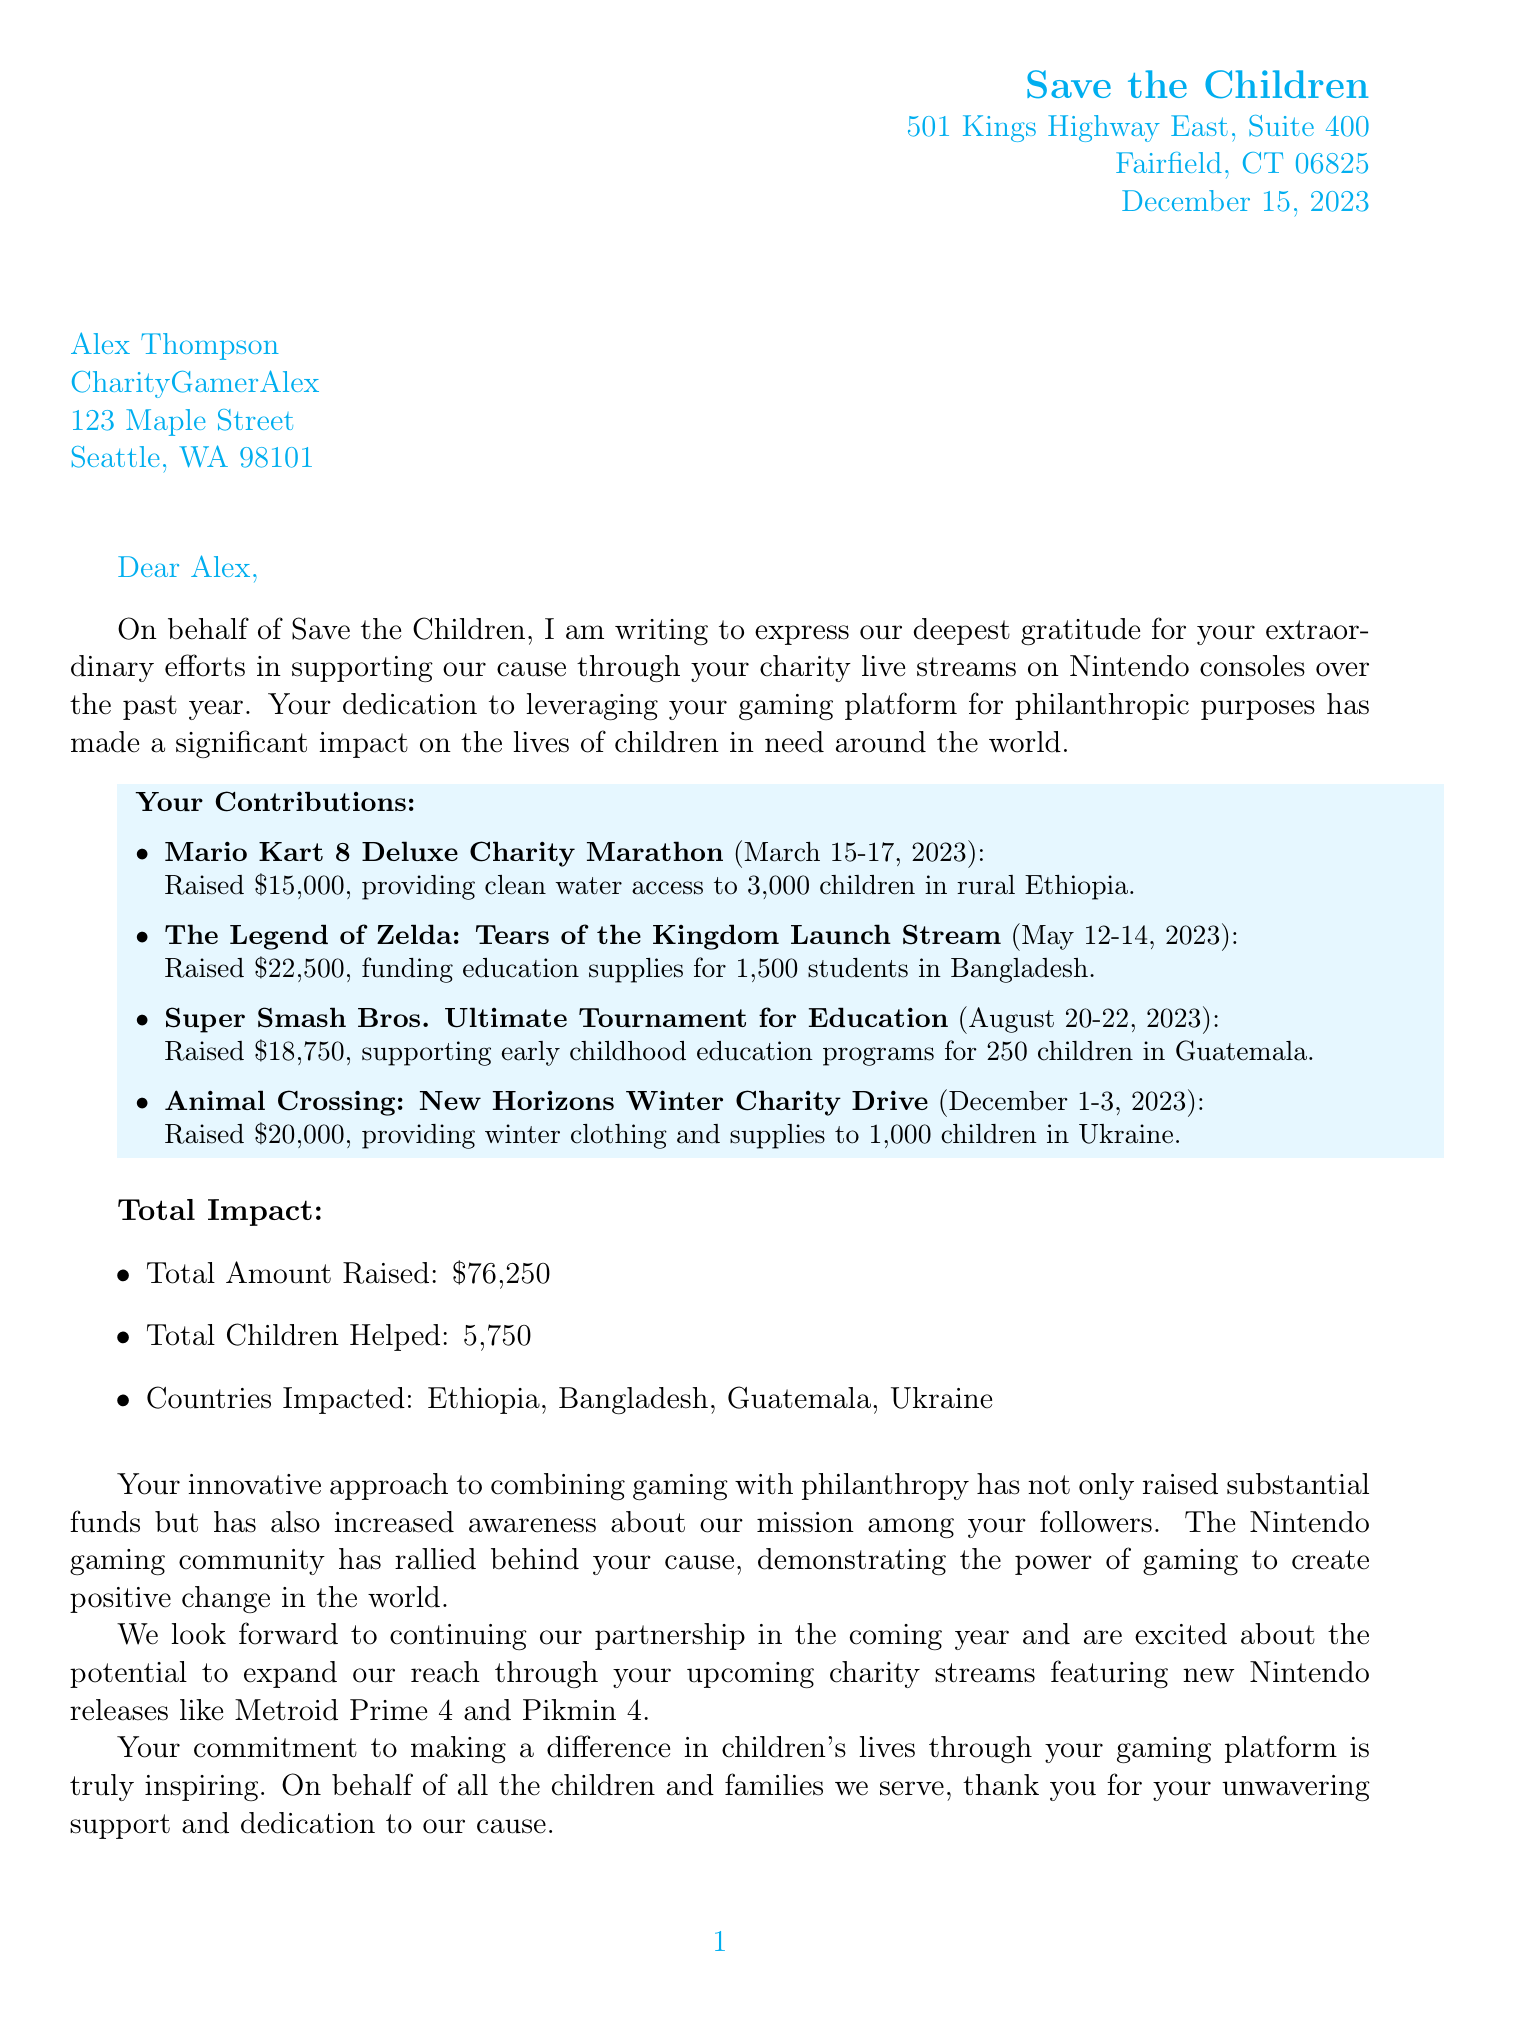What is the total amount raised? The total amount raised is the sum of all contributions from the events listed, which is $76,250.
Answer: $76,250 Who is the recipient of the letter? The recipient is mentioned in the recipient information section of the document as Alex Thompson.
Answer: Alex Thompson What is the address of Save the Children? The address is a specific piece of information located in the letterhead at the top of the document.
Answer: 501 Kings Highway East, Suite 400, Fairfield, CT 06825 How many children were helped in total? The total number of children helped is stated in the total impact section of the document.
Answer: 5,750 What was the date of the Mario Kart 8 Deluxe Charity Marathon? The specific date of this event is listed in the contribution details section.
Answer: March 15-17, 2023 What is the impact of the Super Smash Bros. Ultimate Tournament for Education? This requires understanding the connection between the event and its result, which is provided in the contribution details.
Answer: Supported early childhood education programs for 250 children in Guatemala What is the salutation used in the letter? The salutation is a standard component of a formal letter and is stated right before the introduction paragraph.
Answer: Dear Alex, Who signed the letter? The signature section at the end of the document indicates who has signed the letter.
Answer: Emily Rodriguez What upcoming games are mentioned for future collaboration? This question requires recalling specific titles mentioned in the future collaboration section.
Answer: Metroid Prime 4 and Pikmin 4 